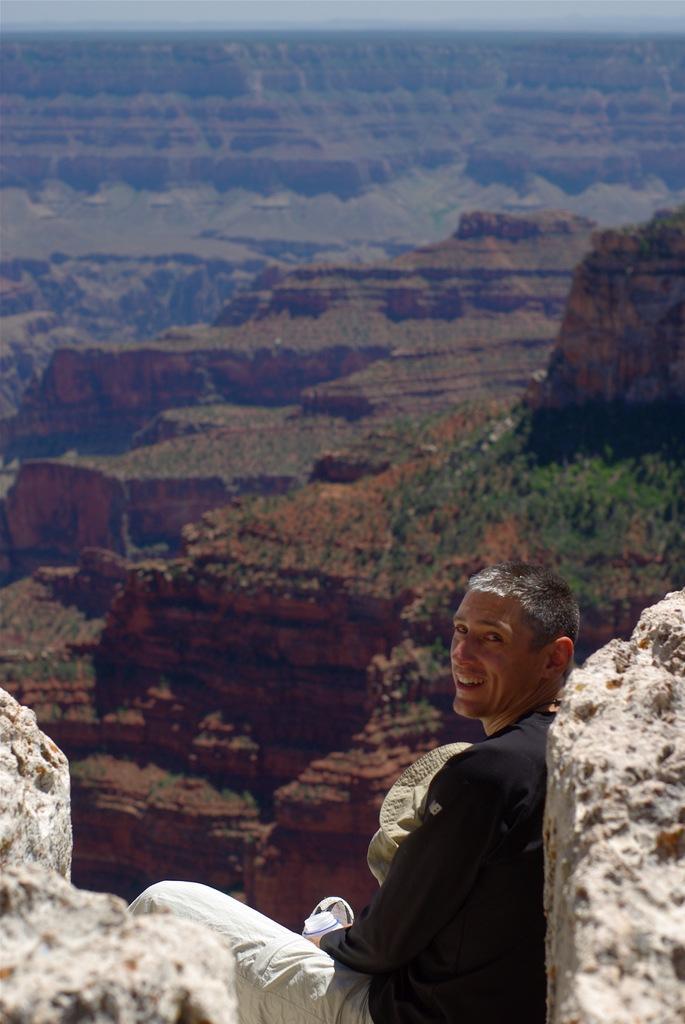Can you describe this image briefly? In this picture there is a man who is wearing black t-shirt, trouser and shoe. He is holding a water bottle and hat. He is smiling. He is sitting near to the stones. In the background we can see the mountains. On the right we can see the plants. 